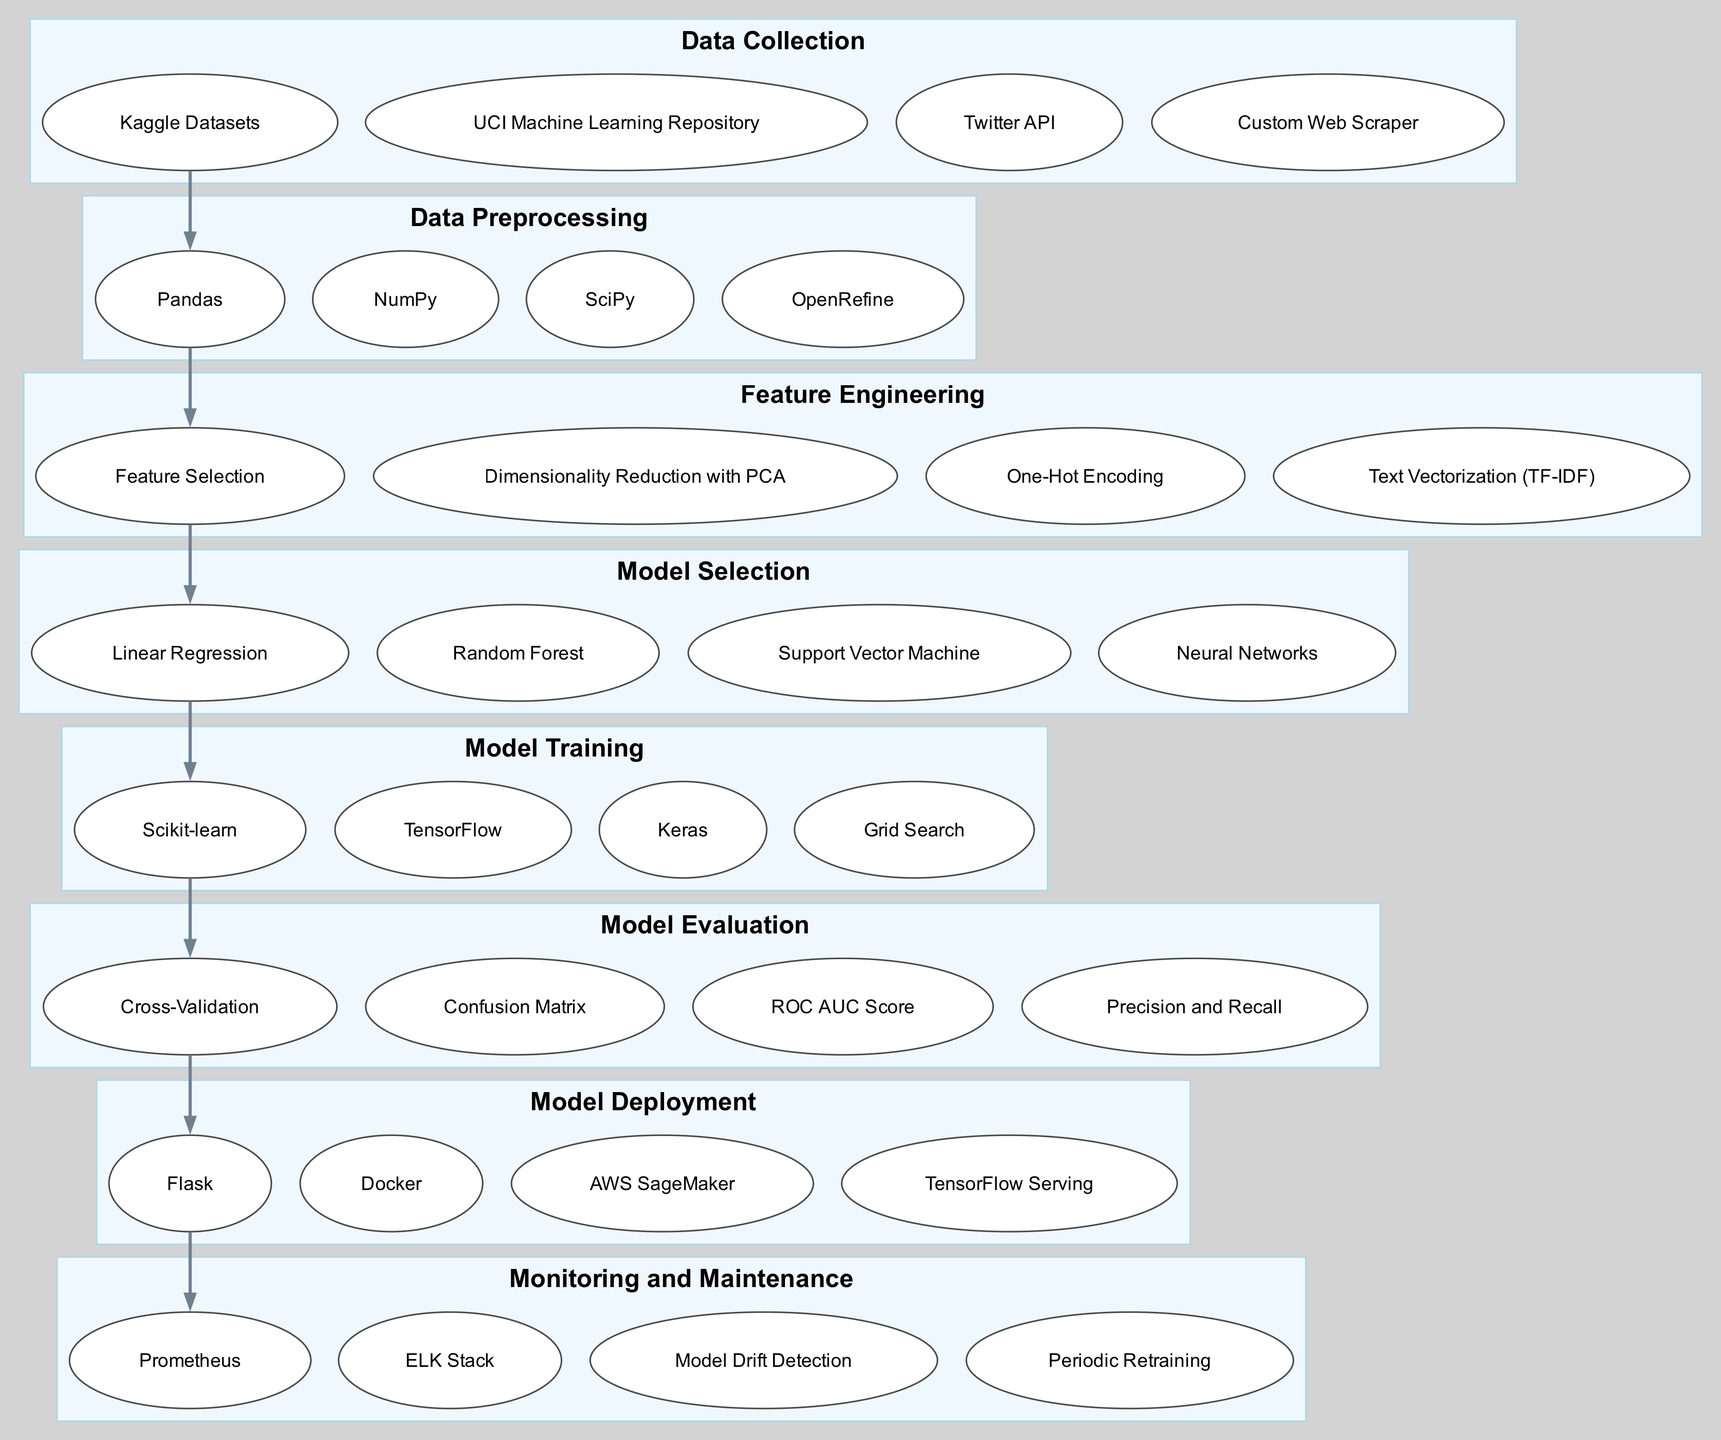What is the first step in the AI research workflow? The first element in the diagram is "Data Collection," indicating that this is the starting point of the workflow.
Answer: Data Collection How many nodes are present in the diagram? The diagram consists of eight main elements, each represented as a node in the workflow.
Answer: Eight What follows after "Model Training" in the workflow? According to the flow of the diagram, "Model Evaluation" is directly connected to "Model Training," which indicates it follows next in the process.
Answer: Model Evaluation Which entity is associated with "Data Preprocessing"? The diagram displays multiple entities under "Data Preprocessing," including "Pandas," which is one of the tools used for this purpose.
Answer: Pandas Which entities are connected to "Monitoring and Maintenance"? The subgraph around "Monitoring and Maintenance" includes entities like "Prometheus" and "Model Drift Detection," showcasing the tools relevant to this step.
Answer: Prometheus, Model Drift Detection What is the main purpose of "Feature Engineering"? The description next to "Feature Engineering" states that the goal is to "create and select relevant features from raw data to improve model performance," summarizing its purpose clearly.
Answer: Improve model performance Which two elements are connected directly before "Model Deployment"? The diagram indicates a direct connection between "Model Evaluation" and "Model Deployment," implying they follow each other in the workflow.
Answer: Model Evaluation, Model Deployment What visual shape represents entities in the diagram? The entities are depicted as ellipses based on the shape defined in the diagram styling, differentiating them from the main nodes which are boxes.
Answer: Ellipses 